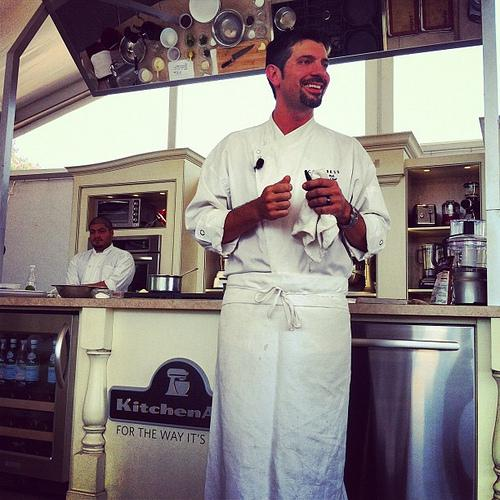Question: who is in white?
Choices:
A. The man.
B. The bride.
C. The flower girl.
D. The boy.
Answer with the letter. Answer: A Question: what does he do?
Choices:
A. Act.
B. Cook.
C. Play a sport.
D. Eat.
Answer with the letter. Answer: B Question: how many men?
Choices:
A. 4.
B. 3.
C. 2.
D. 1.
Answer with the letter. Answer: C Question: what is he doing?
Choices:
A. Talking.
B. Smiling.
C. Walking.
D. Laughing.
Answer with the letter. Answer: B Question: why is he smiling?
Choices:
A. Happy.
B. Had sex.
C. Won the lottery.
D. Got a raise.
Answer with the letter. Answer: A Question: what is he wearing?
Choices:
A. Tie.
B. Suit.
C. Polo shirt.
D. Apron.
Answer with the letter. Answer: D 